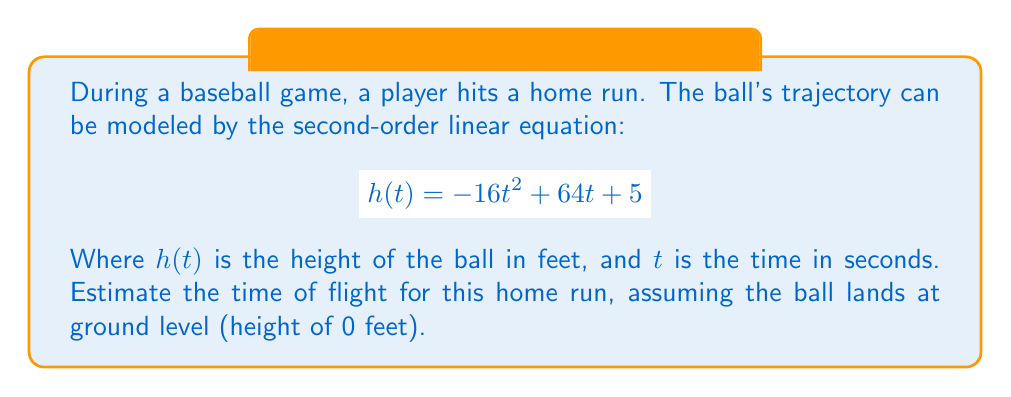What is the answer to this math problem? To find the time of flight, we need to solve the equation $h(t) = 0$. This is because the ball starts at a height above ground level and ends at ground level (0 feet).

1. Set up the equation:
   $$-16t^2 + 64t + 5 = 0$$

2. This is a quadratic equation in the form $at^2 + bt + c = 0$, where:
   $a = -16$, $b = 64$, and $c = 5$

3. We can solve this using the quadratic formula: 
   $$t = \frac{-b \pm \sqrt{b^2 - 4ac}}{2a}$$

4. Substituting our values:
   $$t = \frac{-64 \pm \sqrt{64^2 - 4(-16)(5)}}{2(-16)}$$

5. Simplify:
   $$t = \frac{-64 \pm \sqrt{4096 + 320}}{-32} = \frac{-64 \pm \sqrt{4416}}{-32}$$

6. Calculate:
   $$t = \frac{-64 \pm 66.45}{-32}$$

7. This gives us two solutions:
   $$t_1 = \frac{-64 + 66.45}{-32} \approx 0.08 \text{ seconds}$$
   $$t_2 = \frac{-64 - 66.45}{-32} \approx 4.08 \text{ seconds}$$

8. The negative solution (0.08 seconds) doesn't make physical sense in this context, so we discard it.

Therefore, the estimated time of flight for the home run is approximately 4.08 seconds.
Answer: The estimated time of flight for the home run is approximately 4.08 seconds. 